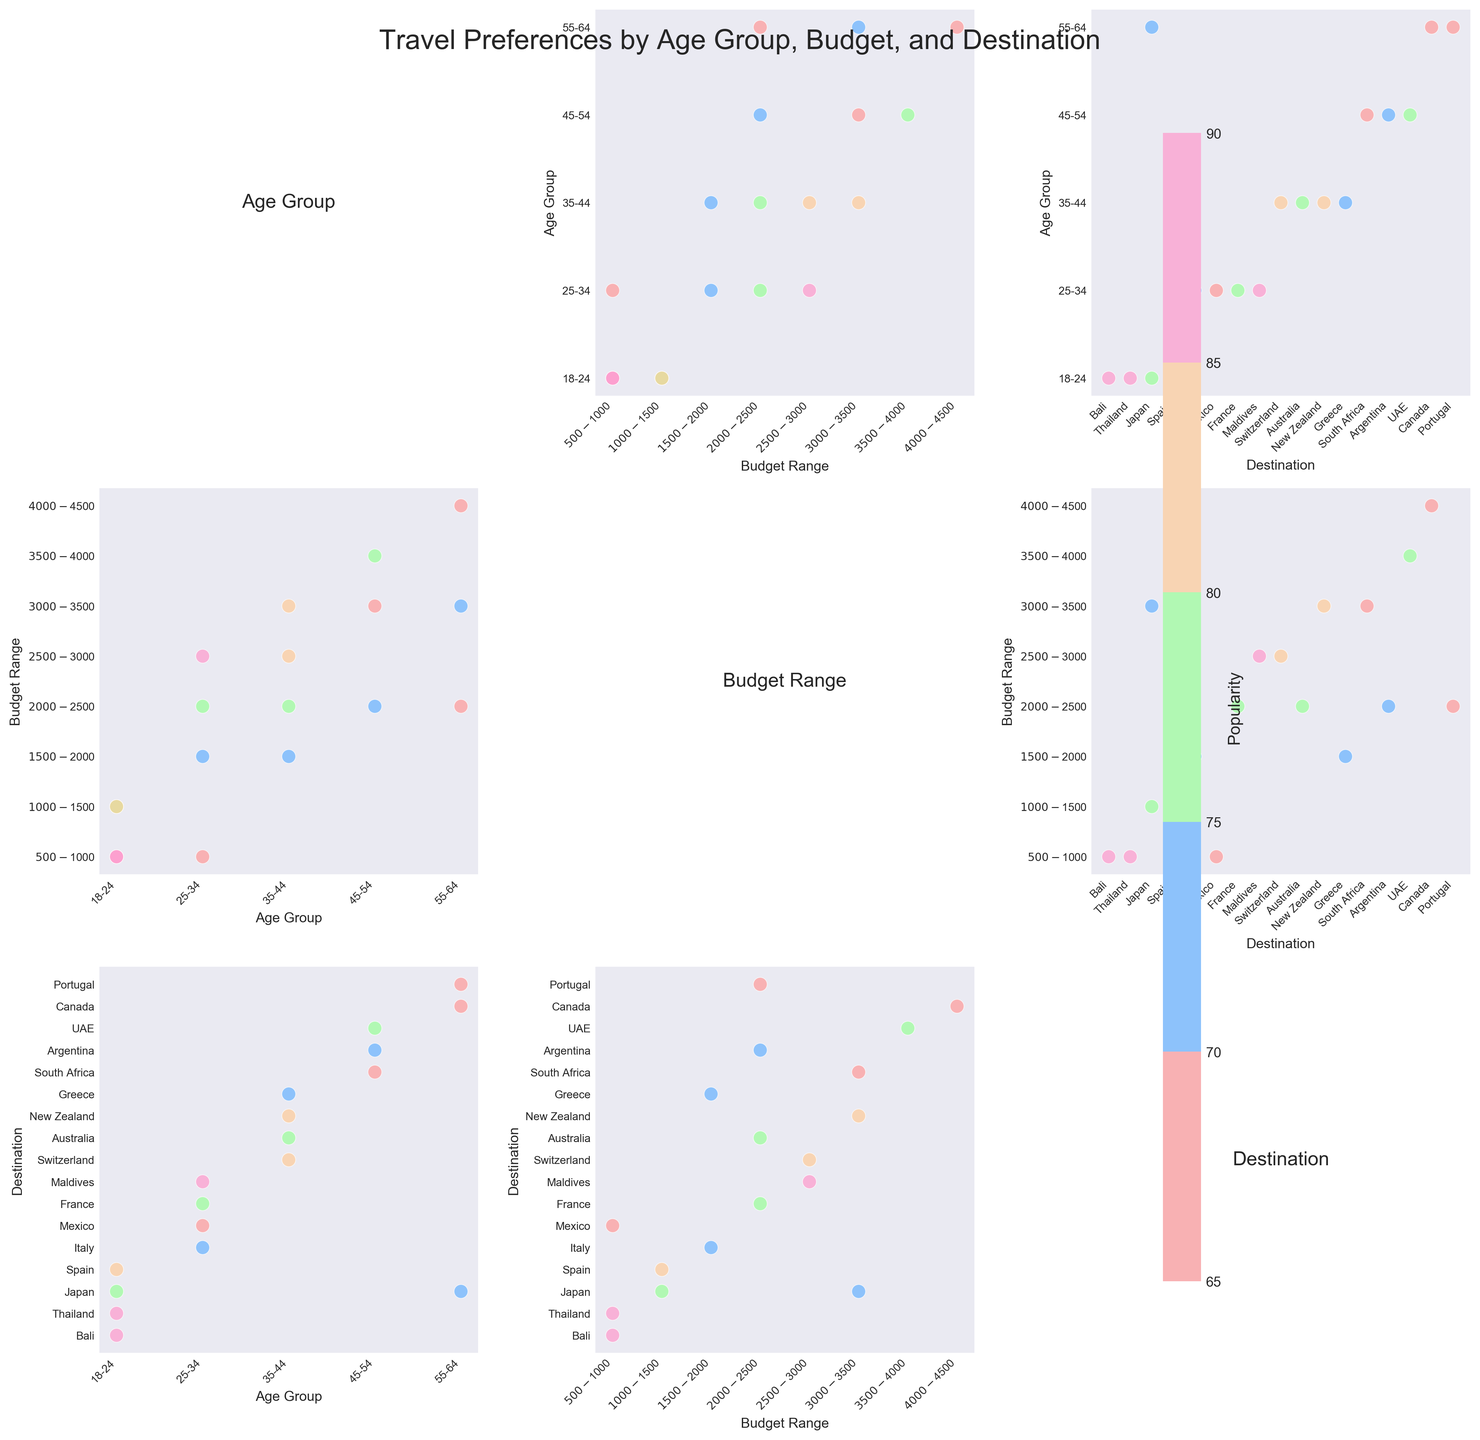what is the title of the figure? The title is located at the top of the figure in a larger font size and provides a brief description of what the figure represents. In this case, the title is "Travel Preferences by Age Group, Budget, and Destination."
Answer: Travel Preferences by Age Group, Budget, and Destination How many different age groups are represented in the figure? By looking at the figure's axes labeled as "Age Group," we count the unique age groups listed. The age groups can be read directly from the tick labels. In this case, there are five: "18-24," "25-34," "35-44," "45-54," and "55-64."
Answer: 5 What is the range of popularity values in the figure? The popularity values are represented by the color of the scatter points, which is indicated by the colorbar. The colorbar shows the range from the minimum to the maximum popularity value. By looking at the colorbar, we can see the range is from 65 to 90.
Answer: 65 to 90 Which age group has the highest popularity for the budget range $500-$1000? To answer this question, locate the "Budget Range" on the x-axis and "$500-$1000" among the labels. Then, find the corresponding "Age Group" on the y-axis with the highest color intensity (closest to 90) within this budget range. The highest per the figure is for the age group "18-24."
Answer: 18-24 What destination is the most popular among the 25-34 age group? Locate the age group "25-34" on the y-axis. Next, look at the "Destination" scatter plot for this age group and identify which destination has the point with the highest color intensity (closest to 90). The most popular destination is the Maldives.
Answer: Maldives Among the age group 45-54, which budget range has the lowest popularity? Locate the age group "45-54" on the y-axis, then identify the scatter points within this category. Look at the scatter plot for the budget ranges within this group and find the one with the lowest color intensity (closest to 65). The budget range with the lowest popularity is $3000-$3500.
Answer: $3000-$3500 Comparing the popularity between the age groups 35-44 and 55-64, which group prefers Switzerland more? Identify the scatter points for Switzerland within the two age groups' "Destination" plots. Compare the color intensity of the Switzerland points for "35-44" and "55-64" age groups. The age group "35-44" has a point with higher color intensity, indicating higher popularity for Switzerland.
Answer: 35-44 Which budget range appears most frequently for the age group 18-24? Locate the age group "18-24" on the y-axis and count the number of scatter points within each budget range for this age group. The budget range that appears most frequently (having the most points) is "$500-$1000" with two occurrences.
Answer: $500-$1000 How does the popularity of Japan compare between the age groups 18-24 and 55-64? Find Japan within the destinations under each age group. Compare the color intensities of the points for Japan in the "18-24" and "55-64" age groups. Considering the color intensities (closer to 90) indicate popularity, Japan is more popular in the 18-24 age group.
Answer: 18-24 